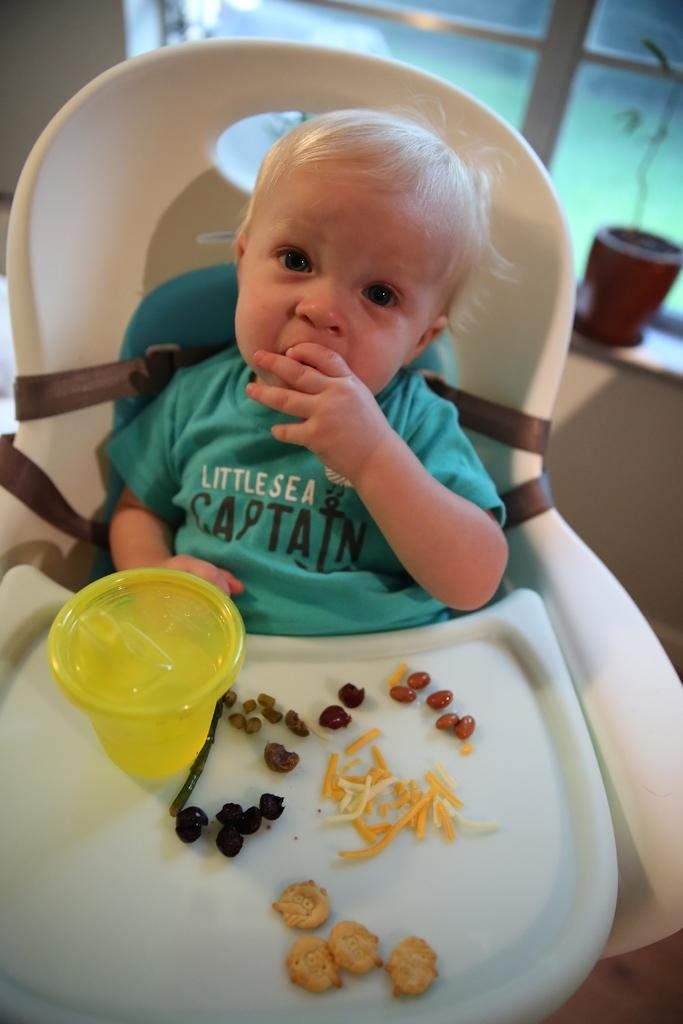What is the main subject of the image? There is a baby in the image. What is the baby doing in the image? The baby is sitting on a chair and eating. What is the baby wearing in the image? The baby is wearing a t-shirt. What else can be seen on the chair in the image? There are food items on the chair. Can you see any snails crawling on the baby's t-shirt in the image? No, there are no snails visible on the baby's t-shirt in the image. Is the baby shaking a clam while sitting on the chair? No, there is no clam present in the image, and the baby is eating, not shaking anything. 